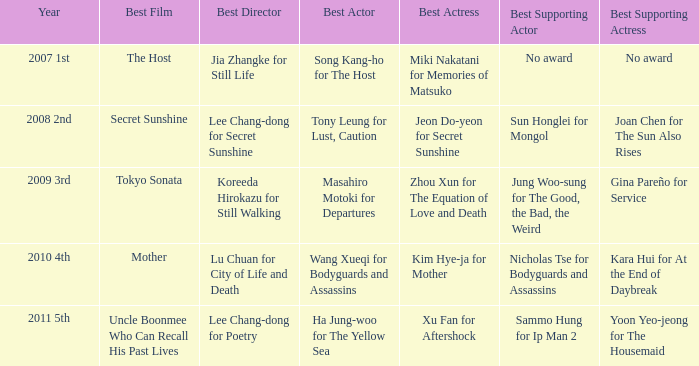Name the year for sammo hung for ip man 2 2011 5th. 